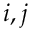Convert formula to latex. <formula><loc_0><loc_0><loc_500><loc_500>i , j</formula> 